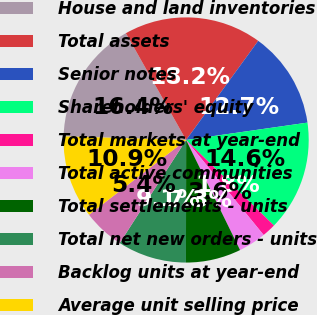Convert chart. <chart><loc_0><loc_0><loc_500><loc_500><pie_chart><fcel>House and land inventories<fcel>Total assets<fcel>Senior notes<fcel>Shareholders' equity<fcel>Total markets at year-end<fcel>Total active communities<fcel>Total settlements - units<fcel>Total net new orders - units<fcel>Backlog units at year-end<fcel>Average unit selling price<nl><fcel>16.36%<fcel>18.18%<fcel>12.73%<fcel>14.55%<fcel>1.82%<fcel>3.64%<fcel>7.27%<fcel>9.09%<fcel>5.45%<fcel>10.91%<nl></chart> 